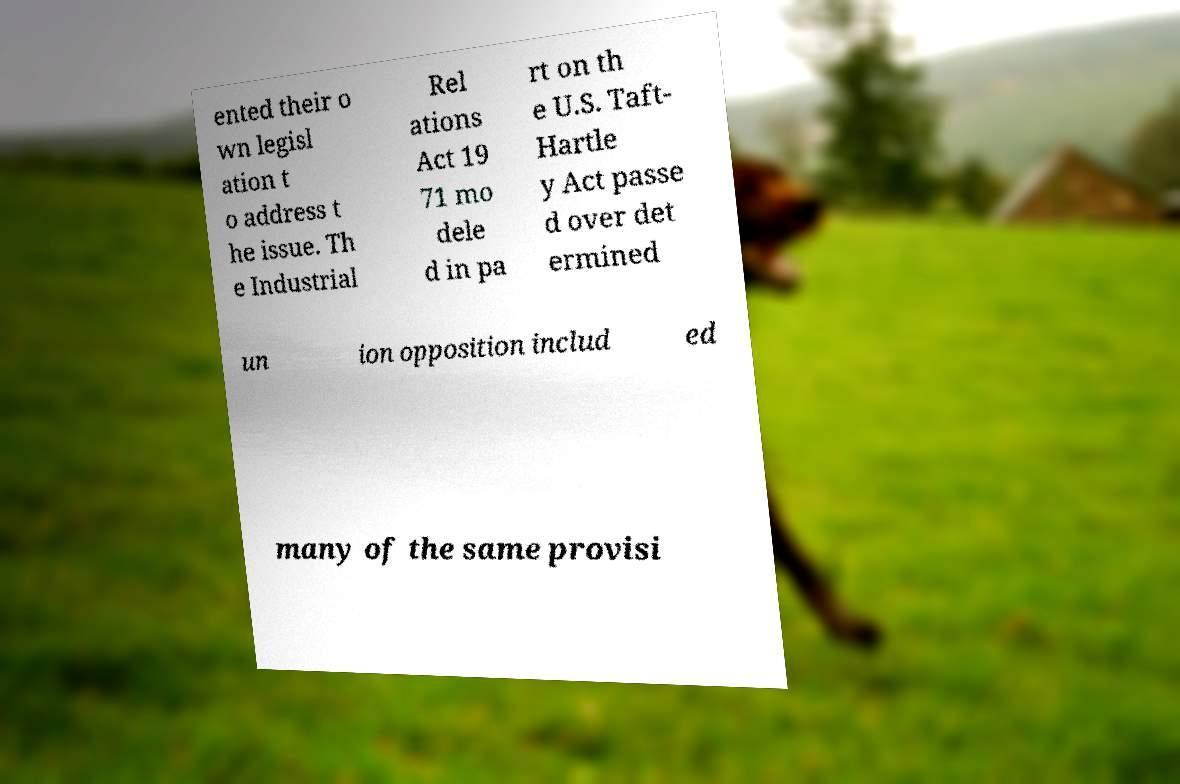Please read and relay the text visible in this image. What does it say? ented their o wn legisl ation t o address t he issue. Th e Industrial Rel ations Act 19 71 mo dele d in pa rt on th e U.S. Taft- Hartle y Act passe d over det ermined un ion opposition includ ed many of the same provisi 